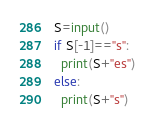Convert code to text. <code><loc_0><loc_0><loc_500><loc_500><_Python_>S=input()
if S[-1]=="s":
  print(S+"es")
else:
  print(S+"s")</code> 